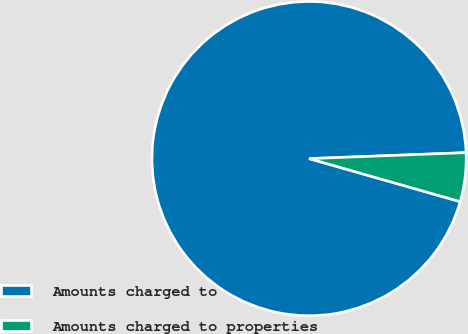<chart> <loc_0><loc_0><loc_500><loc_500><pie_chart><fcel>Amounts charged to<fcel>Amounts charged to properties<nl><fcel>94.98%<fcel>5.02%<nl></chart> 